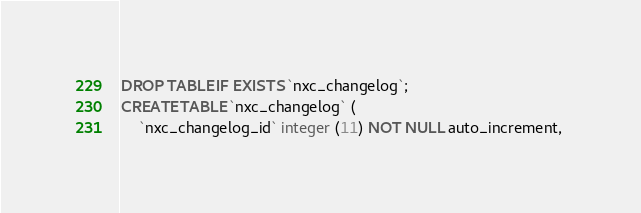Convert code to text. <code><loc_0><loc_0><loc_500><loc_500><_SQL_>DROP TABLE IF EXISTS `nxc_changelog`;
CREATE TABLE `nxc_changelog` (
	`nxc_changelog_id` integer (11) NOT NULL auto_increment, </code> 